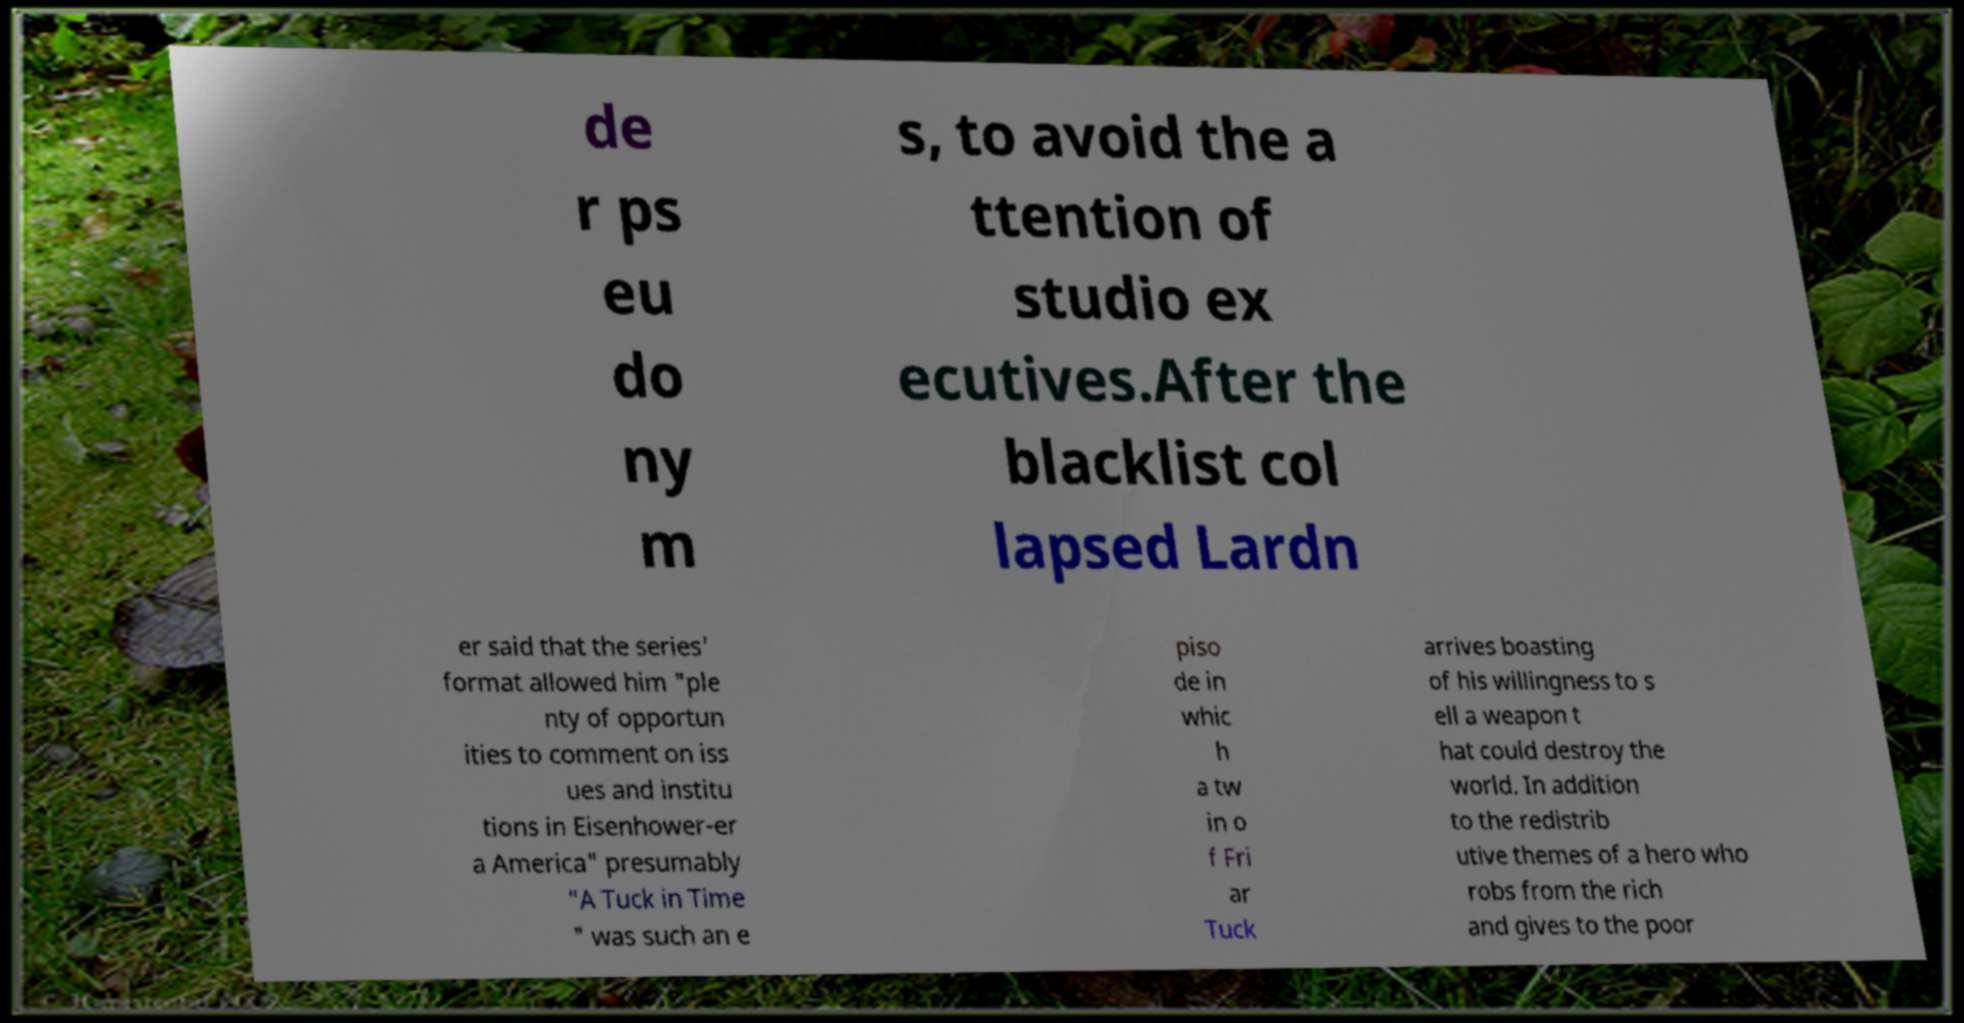For documentation purposes, I need the text within this image transcribed. Could you provide that? de r ps eu do ny m s, to avoid the a ttention of studio ex ecutives.After the blacklist col lapsed Lardn er said that the series' format allowed him "ple nty of opportun ities to comment on iss ues and institu tions in Eisenhower-er a America" presumably "A Tuck in Time " was such an e piso de in whic h a tw in o f Fri ar Tuck arrives boasting of his willingness to s ell a weapon t hat could destroy the world. In addition to the redistrib utive themes of a hero who robs from the rich and gives to the poor 